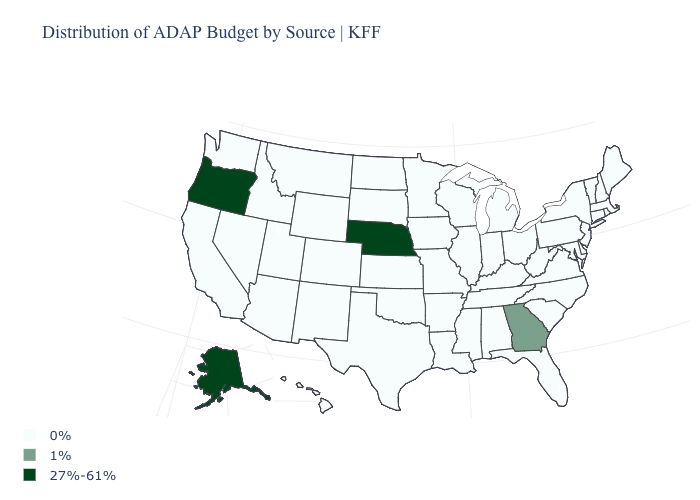How many symbols are there in the legend?
Quick response, please. 3. What is the value of Indiana?
Quick response, please. 0%. Name the states that have a value in the range 27%-61%?
Answer briefly. Alaska, Nebraska, Oregon. Does Connecticut have a lower value than Florida?
Short answer required. No. What is the value of Missouri?
Concise answer only. 0%. What is the value of Kentucky?
Keep it brief. 0%. Name the states that have a value in the range 1%?
Write a very short answer. Georgia. Name the states that have a value in the range 1%?
Answer briefly. Georgia. What is the value of Pennsylvania?
Write a very short answer. 0%. Which states have the lowest value in the USA?
Concise answer only. Alabama, Arizona, Arkansas, California, Colorado, Connecticut, Delaware, Florida, Hawaii, Idaho, Illinois, Indiana, Iowa, Kansas, Kentucky, Louisiana, Maine, Maryland, Massachusetts, Michigan, Minnesota, Mississippi, Missouri, Montana, Nevada, New Hampshire, New Jersey, New Mexico, New York, North Carolina, North Dakota, Ohio, Oklahoma, Pennsylvania, Rhode Island, South Carolina, South Dakota, Tennessee, Texas, Utah, Vermont, Virginia, Washington, West Virginia, Wisconsin, Wyoming. Does Illinois have the lowest value in the MidWest?
Keep it brief. Yes. What is the highest value in states that border New Hampshire?
Give a very brief answer. 0%. What is the value of California?
Be succinct. 0%. What is the value of Ohio?
Give a very brief answer. 0%. Among the states that border California , which have the lowest value?
Write a very short answer. Arizona, Nevada. 